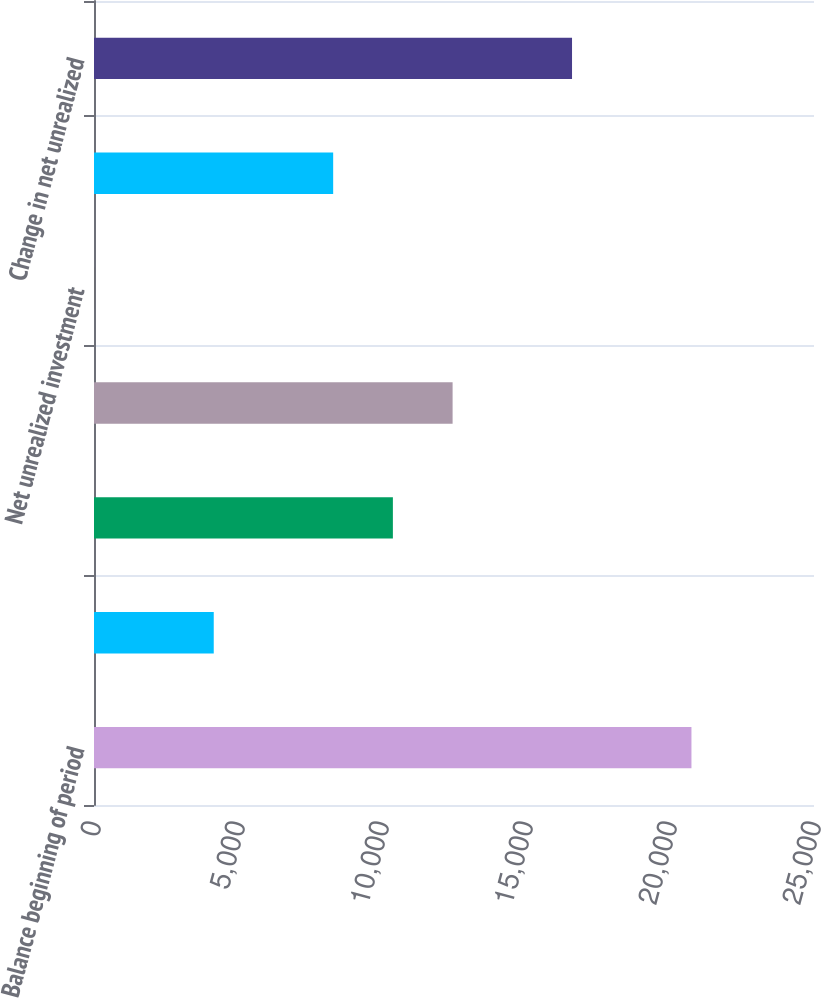Convert chart to OTSL. <chart><loc_0><loc_0><loc_500><loc_500><bar_chart><fcel>Balance beginning of period<fcel>Cumulative effect of change in<fcel>Unnamed: 2<fcel>DACandVOBA<fcel>Net unrealized investment<fcel>Balance end of period<fcel>Change in net unrealized<nl><fcel>20745<fcel>4157.8<fcel>10378<fcel>12451.4<fcel>11<fcel>8304.6<fcel>16598.2<nl></chart> 